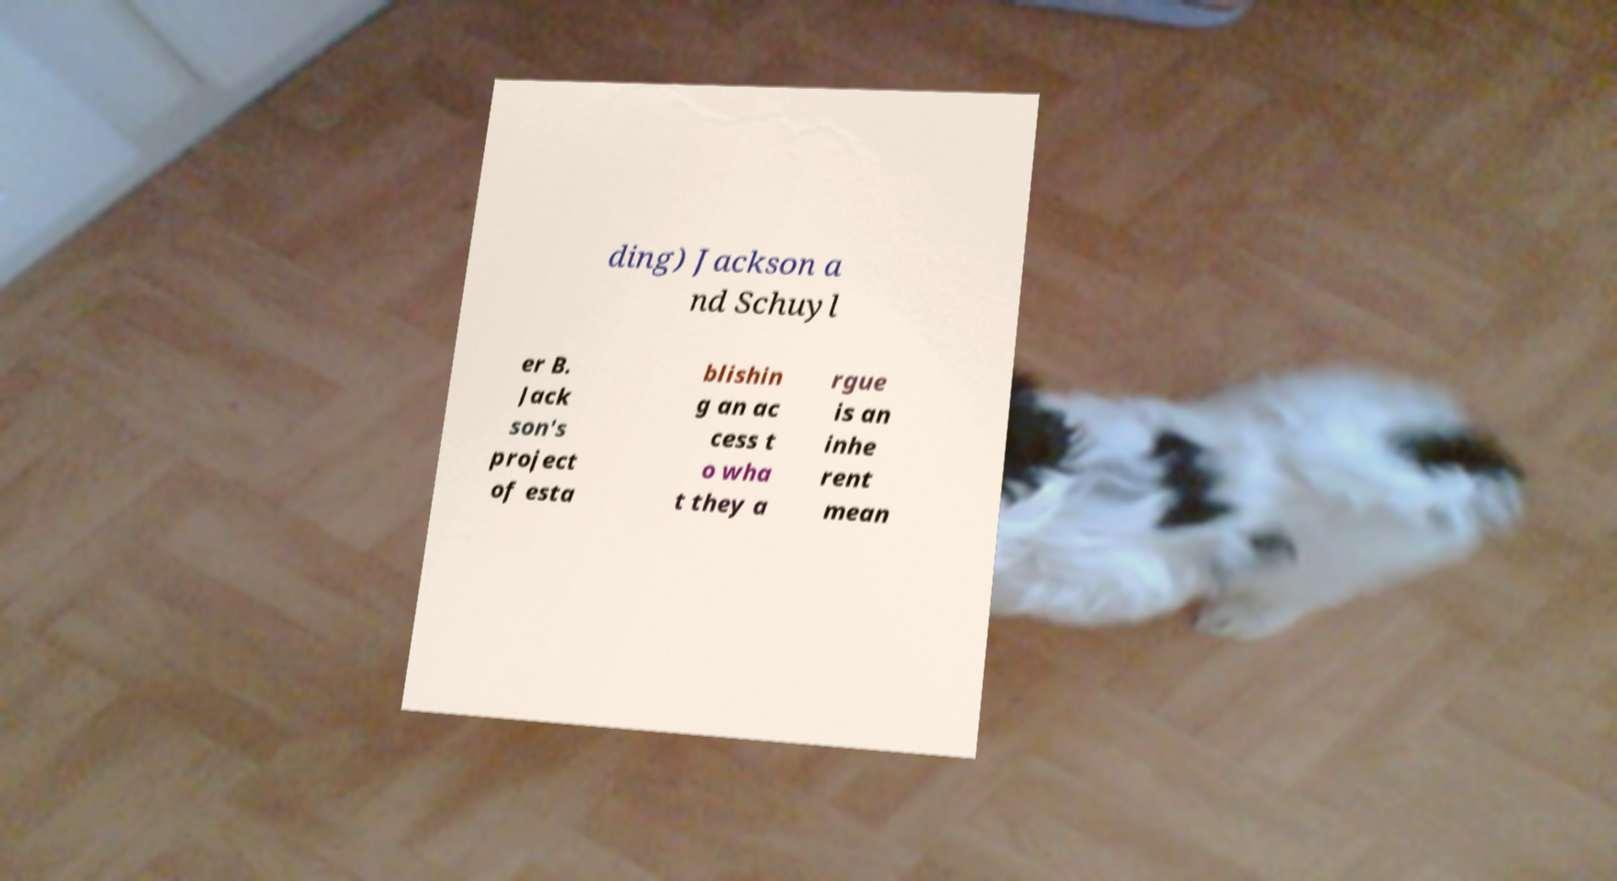What messages or text are displayed in this image? I need them in a readable, typed format. ding) Jackson a nd Schuyl er B. Jack son's project of esta blishin g an ac cess t o wha t they a rgue is an inhe rent mean 